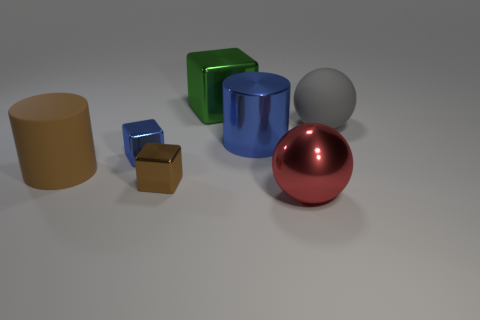Add 2 tiny red shiny objects. How many objects exist? 9 Subtract all cylinders. How many objects are left? 5 Add 4 red cylinders. How many red cylinders exist? 4 Subtract 0 yellow cylinders. How many objects are left? 7 Subtract all big gray balls. Subtract all rubber objects. How many objects are left? 4 Add 5 tiny blue metallic blocks. How many tiny blue metallic blocks are left? 6 